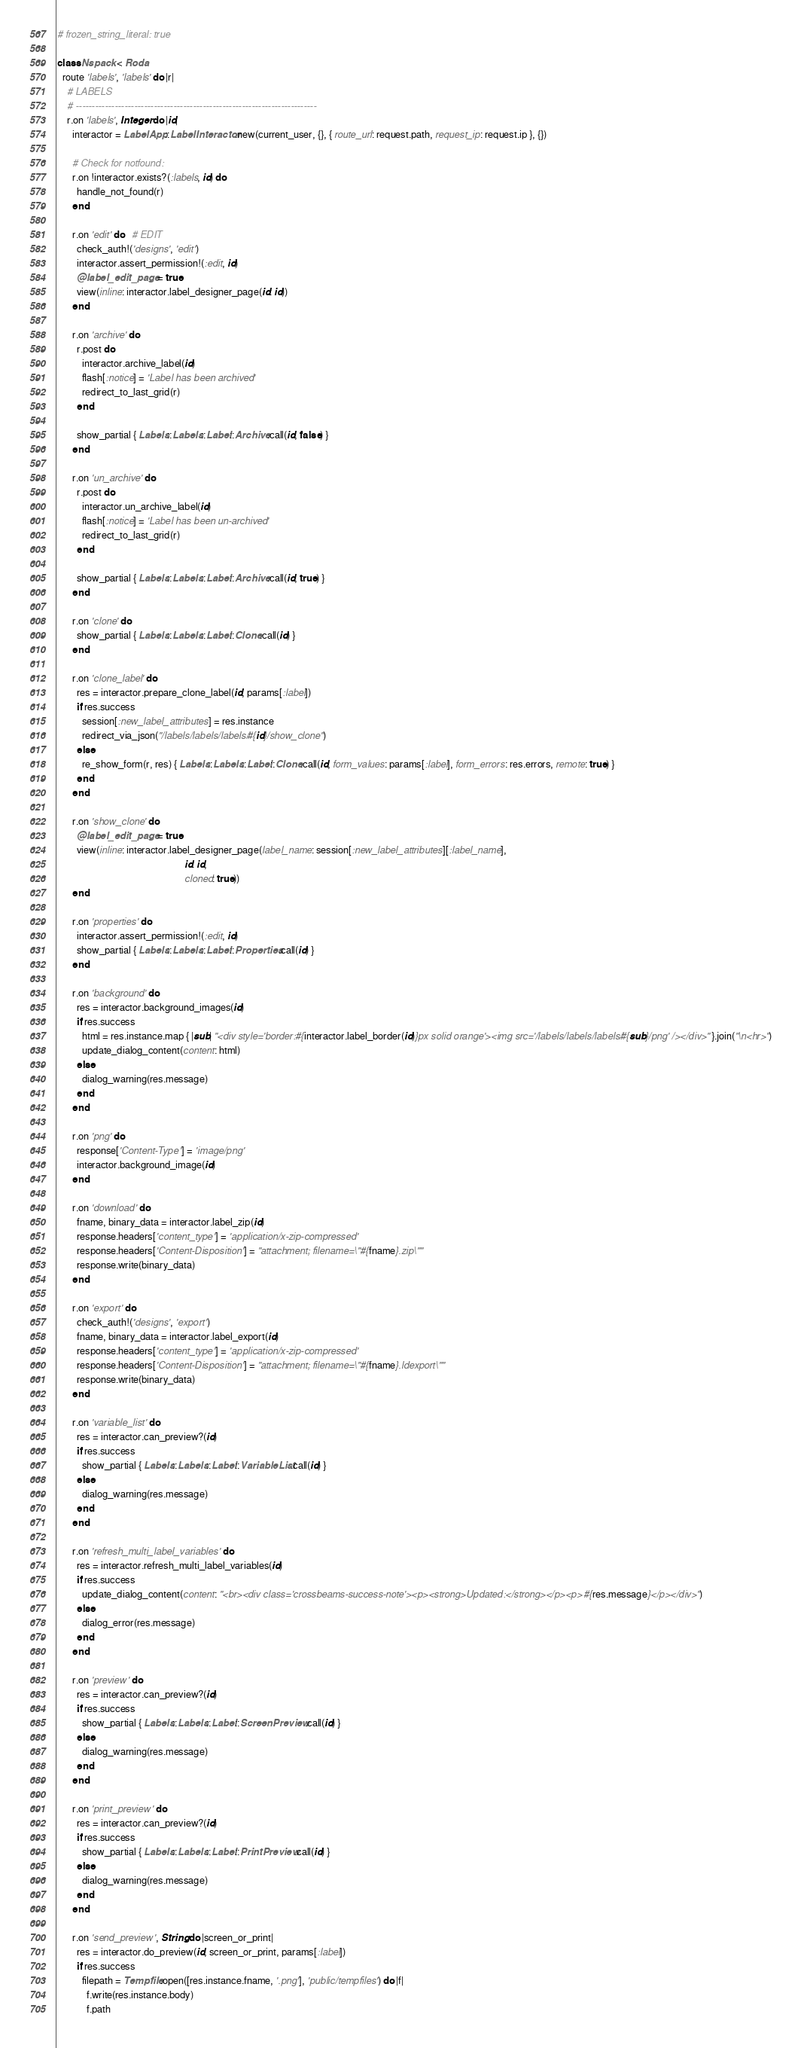Convert code to text. <code><loc_0><loc_0><loc_500><loc_500><_Ruby_># frozen_string_literal: true

class Nspack < Roda
  route 'labels', 'labels' do |r|
    # LABELS
    # --------------------------------------------------------------------------
    r.on 'labels', Integer do |id|
      interactor = LabelApp::LabelInteractor.new(current_user, {}, { route_url: request.path, request_ip: request.ip }, {})

      # Check for notfound:
      r.on !interactor.exists?(:labels, id) do
        handle_not_found(r)
      end

      r.on 'edit' do   # EDIT
        check_auth!('designs', 'edit')
        interactor.assert_permission!(:edit, id)
        @label_edit_page = true
        view(inline: interactor.label_designer_page(id: id))
      end

      r.on 'archive' do
        r.post do
          interactor.archive_label(id)
          flash[:notice] = 'Label has been archived'
          redirect_to_last_grid(r)
        end

        show_partial { Labels::Labels::Label::Archive.call(id, false) }
      end

      r.on 'un_archive' do
        r.post do
          interactor.un_archive_label(id)
          flash[:notice] = 'Label has been un-archived'
          redirect_to_last_grid(r)
        end

        show_partial { Labels::Labels::Label::Archive.call(id, true) }
      end

      r.on 'clone' do
        show_partial { Labels::Labels::Label::Clone.call(id) }
      end

      r.on 'clone_label' do
        res = interactor.prepare_clone_label(id, params[:label])
        if res.success
          session[:new_label_attributes] = res.instance
          redirect_via_json("/labels/labels/labels/#{id}/show_clone")
        else
          re_show_form(r, res) { Labels::Labels::Label::Clone.call(id, form_values: params[:label], form_errors: res.errors, remote: true) }
        end
      end

      r.on 'show_clone' do
        @label_edit_page = true
        view(inline: interactor.label_designer_page(label_name: session[:new_label_attributes][:label_name],
                                                    id: id,
                                                    cloned: true))
      end

      r.on 'properties' do
        interactor.assert_permission!(:edit, id)
        show_partial { Labels::Labels::Label::Properties.call(id) }
      end

      r.on 'background' do
        res = interactor.background_images(id)
        if res.success
          html = res.instance.map { |sub| "<div style='border:#{interactor.label_border(id)}px solid orange'><img src='/labels/labels/labels/#{sub}/png' /></div>" }.join("\n<hr>")
          update_dialog_content(content: html)
        else
          dialog_warning(res.message)
        end
      end

      r.on 'png' do
        response['Content-Type'] = 'image/png'
        interactor.background_image(id)
      end

      r.on 'download' do
        fname, binary_data = interactor.label_zip(id)
        response.headers['content_type'] = 'application/x-zip-compressed'
        response.headers['Content-Disposition'] = "attachment; filename=\"#{fname}.zip\""
        response.write(binary_data)
      end

      r.on 'export' do
        check_auth!('designs', 'export')
        fname, binary_data = interactor.label_export(id)
        response.headers['content_type'] = 'application/x-zip-compressed'
        response.headers['Content-Disposition'] = "attachment; filename=\"#{fname}.ldexport\""
        response.write(binary_data)
      end

      r.on 'variable_list' do
        res = interactor.can_preview?(id)
        if res.success
          show_partial { Labels::Labels::Label::VariableList.call(id) }
        else
          dialog_warning(res.message)
        end
      end

      r.on 'refresh_multi_label_variables' do
        res = interactor.refresh_multi_label_variables(id)
        if res.success
          update_dialog_content(content: "<br><div class='crossbeams-success-note'><p><strong>Updated:</strong></p><p>#{res.message}</p></div>")
        else
          dialog_error(res.message)
        end
      end

      r.on 'preview' do
        res = interactor.can_preview?(id)
        if res.success
          show_partial { Labels::Labels::Label::ScreenPreview.call(id) }
        else
          dialog_warning(res.message)
        end
      end

      r.on 'print_preview' do
        res = interactor.can_preview?(id)
        if res.success
          show_partial { Labels::Labels::Label::PrintPreview.call(id) }
        else
          dialog_warning(res.message)
        end
      end

      r.on 'send_preview', String do |screen_or_print|
        res = interactor.do_preview(id, screen_or_print, params[:label])
        if res.success
          filepath = Tempfile.open([res.instance.fname, '.png'], 'public/tempfiles') do |f|
            f.write(res.instance.body)
            f.path</code> 